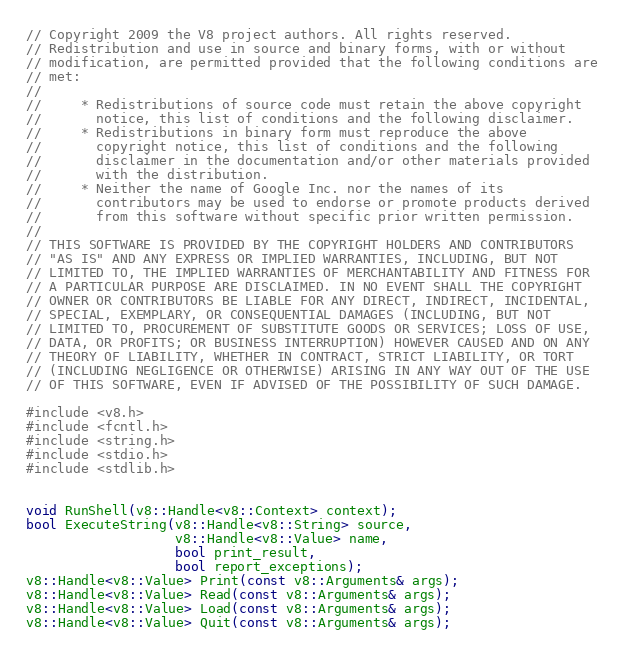Convert code to text. <code><loc_0><loc_0><loc_500><loc_500><_C++_>// Copyright 2009 the V8 project authors. All rights reserved.
// Redistribution and use in source and binary forms, with or without
// modification, are permitted provided that the following conditions are
// met:
//
//     * Redistributions of source code must retain the above copyright
//       notice, this list of conditions and the following disclaimer.
//     * Redistributions in binary form must reproduce the above
//       copyright notice, this list of conditions and the following
//       disclaimer in the documentation and/or other materials provided
//       with the distribution.
//     * Neither the name of Google Inc. nor the names of its
//       contributors may be used to endorse or promote products derived
//       from this software without specific prior written permission.
//
// THIS SOFTWARE IS PROVIDED BY THE COPYRIGHT HOLDERS AND CONTRIBUTORS
// "AS IS" AND ANY EXPRESS OR IMPLIED WARRANTIES, INCLUDING, BUT NOT
// LIMITED TO, THE IMPLIED WARRANTIES OF MERCHANTABILITY AND FITNESS FOR
// A PARTICULAR PURPOSE ARE DISCLAIMED. IN NO EVENT SHALL THE COPYRIGHT
// OWNER OR CONTRIBUTORS BE LIABLE FOR ANY DIRECT, INDIRECT, INCIDENTAL,
// SPECIAL, EXEMPLARY, OR CONSEQUENTIAL DAMAGES (INCLUDING, BUT NOT
// LIMITED TO, PROCUREMENT OF SUBSTITUTE GOODS OR SERVICES; LOSS OF USE,
// DATA, OR PROFITS; OR BUSINESS INTERRUPTION) HOWEVER CAUSED AND ON ANY
// THEORY OF LIABILITY, WHETHER IN CONTRACT, STRICT LIABILITY, OR TORT
// (INCLUDING NEGLIGENCE OR OTHERWISE) ARISING IN ANY WAY OUT OF THE USE
// OF THIS SOFTWARE, EVEN IF ADVISED OF THE POSSIBILITY OF SUCH DAMAGE.

#include <v8.h>
#include <fcntl.h>
#include <string.h>
#include <stdio.h>
#include <stdlib.h>


void RunShell(v8::Handle<v8::Context> context);
bool ExecuteString(v8::Handle<v8::String> source,
                   v8::Handle<v8::Value> name,
                   bool print_result,
                   bool report_exceptions);
v8::Handle<v8::Value> Print(const v8::Arguments& args);
v8::Handle<v8::Value> Read(const v8::Arguments& args);
v8::Handle<v8::Value> Load(const v8::Arguments& args);
v8::Handle<v8::Value> Quit(const v8::Arguments& args);</code> 